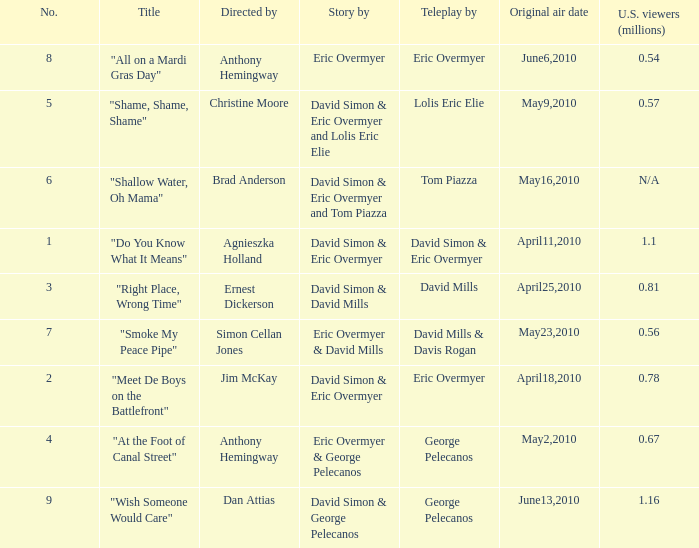Name the us viewers directed by christine moore 0.57. 